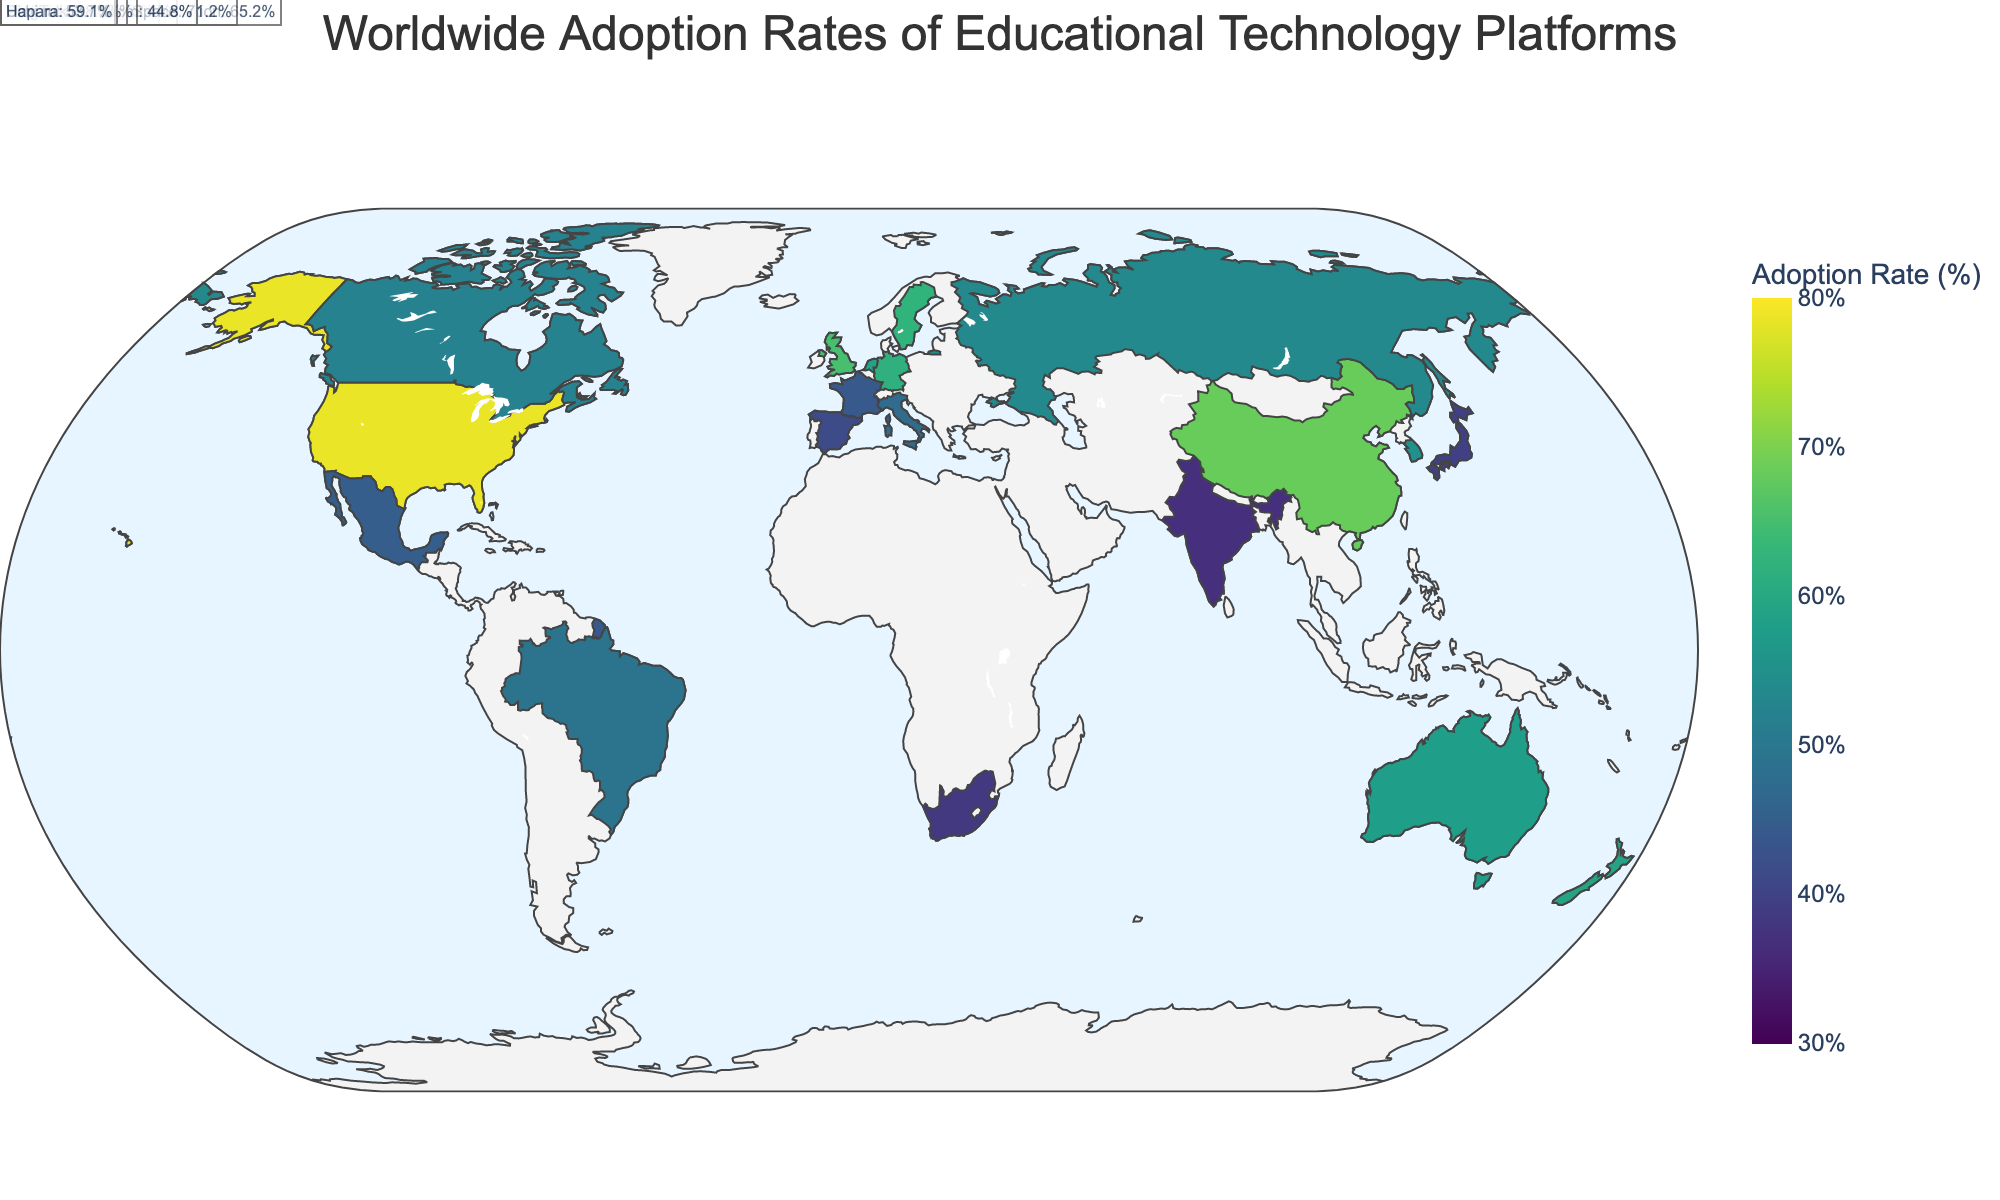What's the title of the figure? The title of the figure is usually located at the top of the plot. It precis the main message or focus of the visual data shown below it.
Answer: Worldwide Adoption Rates of Educational Technology Platforms Which country has the highest adoption rate and which platform is adopted there? To find the highest adoption rate, look for the country with the highest value in the color scale on the plot. Read the corresponding platform name.
Answer: United States, Google Classroom What is the difference in adoption rate between the United States and Japan? Locate the adoption rates of the United States and Japan on the plot and subtract the Japanese rate from the US rate. The US adoption rate is 78.5% and Japan's is 39.6%, so the difference is 78.5 - 39.6.
Answer: 38.9 Which countries have an adoption rate above 60%? Identify the countries on the plot that are colored within the highest decile of the color scale (typically darker/stronger colors if using the Viridis color scale). Check the corresponding adoption rates to ensure they exceed 60%.
Answer: United States, United Kingdom, Germany, Sweden, Singapore, China Count the number of countries that use Google Classroom as their educational technology platform. Locate all the mentions of "Google Classroom" on the plot and count the number of countries associated with this platform.
Answer: 3 What is the average adoption rate for the platforms in European countries listed in the data? Identify all European countries listed and their corresponding adoption rates, sum these rates, and divide by the number of European countries. The European countries are the United Kingdom (65.2), Germany (61.7), France (43.9), Italy (47.6), Spain (41.5), Netherlands (58.9), and Sweden (62.4). Average = (65.2 + 61.7 + 43.9 + 47.6 + 41.5 + 58.9 + 62.4)/7.
Answer: 54.5 Which platform is used in New Zealand and what is its adoption rate? Locate New Zealand on the plot and read the associated platform and adoption rate.
Answer: Hapara, 59.1 Compare the adoption rates of Moodle in Germany and South Africa. Which country has a higher rate? Identify the adoption rates of Moodle for both Germany and South Africa and compare these rates. Germany has an adoption rate of 61.7% and South Africa has 38.5%, so Germany has a higher rate.
Answer: Germany What is the range of adoption rates shown in the plot? Assess the color scale range and the min-max values of the adoption rates. The range is from the lowest rate (36.7% in India) to the highest rate (78.5% in the United States).
Answer: 36.7 to 78.5 How many countries have an adoption rate below 50%? Identify the countries on the plot with rates below 50% by cross-referencing their color/shade and the corresponding numerical values. Count these countries.
Answer: 7 